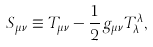Convert formula to latex. <formula><loc_0><loc_0><loc_500><loc_500>S _ { \mu \nu } \equiv T _ { \mu \nu } - \frac { 1 } { 2 } g _ { \mu \nu } T ^ { \lambda } _ { \lambda } ,</formula> 